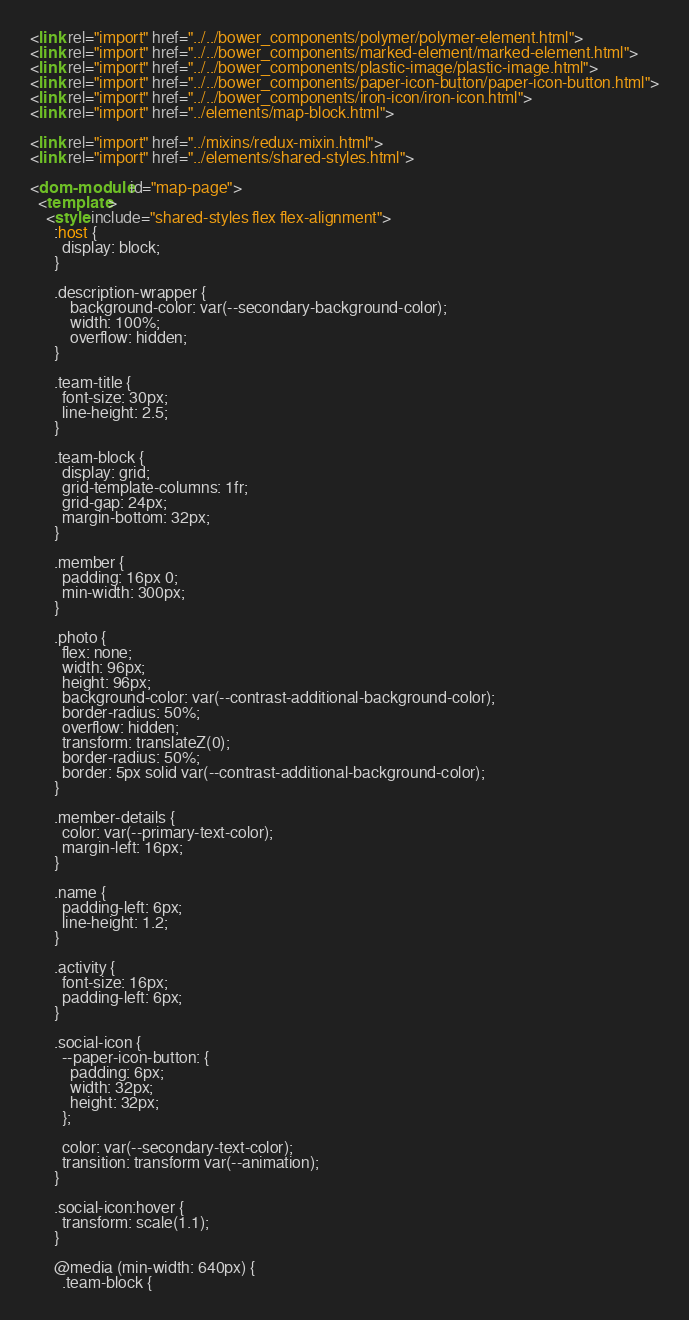<code> <loc_0><loc_0><loc_500><loc_500><_HTML_><link rel="import" href="../../bower_components/polymer/polymer-element.html">
<link rel="import" href="../../bower_components/marked-element/marked-element.html">
<link rel="import" href="../../bower_components/plastic-image/plastic-image.html">
<link rel="import" href="../../bower_components/paper-icon-button/paper-icon-button.html">
<link rel="import" href="../../bower_components/iron-icon/iron-icon.html">
<link rel="import" href="../elements/map-block.html">

<link rel="import" href="../mixins/redux-mixin.html">
<link rel="import" href="../elements/shared-styles.html">

<dom-module id="map-page">
  <template>
    <style include="shared-styles flex flex-alignment">
      :host {
        display: block;
      }

      .description-wrapper {
          background-color: var(--secondary-background-color);
          width: 100%;
          overflow: hidden;
      }

      .team-title {
        font-size: 30px;
        line-height: 2.5;
      }

      .team-block {
        display: grid;
        grid-template-columns: 1fr;
        grid-gap: 24px;
        margin-bottom: 32px;
      }

      .member {
        padding: 16px 0;
        min-width: 300px;
      }

      .photo {
        flex: none;
        width: 96px;
        height: 96px;
        background-color: var(--contrast-additional-background-color);
        border-radius: 50%;
        overflow: hidden;
        transform: translateZ(0);
        border-radius: 50%;
        border: 5px solid var(--contrast-additional-background-color);
      }

      .member-details {
        color: var(--primary-text-color);
        margin-left: 16px;
      }

      .name {
        padding-left: 6px;
        line-height: 1.2;
      }

      .activity {
        font-size: 16px;
        padding-left: 6px;
      }

      .social-icon {
        --paper-icon-button: {
          padding: 6px;
          width: 32px;
          height: 32px;
        };

        color: var(--secondary-text-color);
        transition: transform var(--animation);
      }

      .social-icon:hover {
        transform: scale(1.1);
      }

      @media (min-width: 640px) {
        .team-block {</code> 